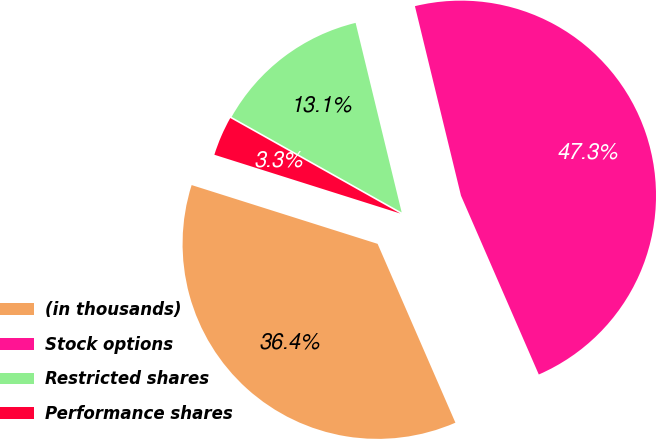Convert chart. <chart><loc_0><loc_0><loc_500><loc_500><pie_chart><fcel>(in thousands)<fcel>Stock options<fcel>Restricted shares<fcel>Performance shares<nl><fcel>36.4%<fcel>47.26%<fcel>13.06%<fcel>3.27%<nl></chart> 